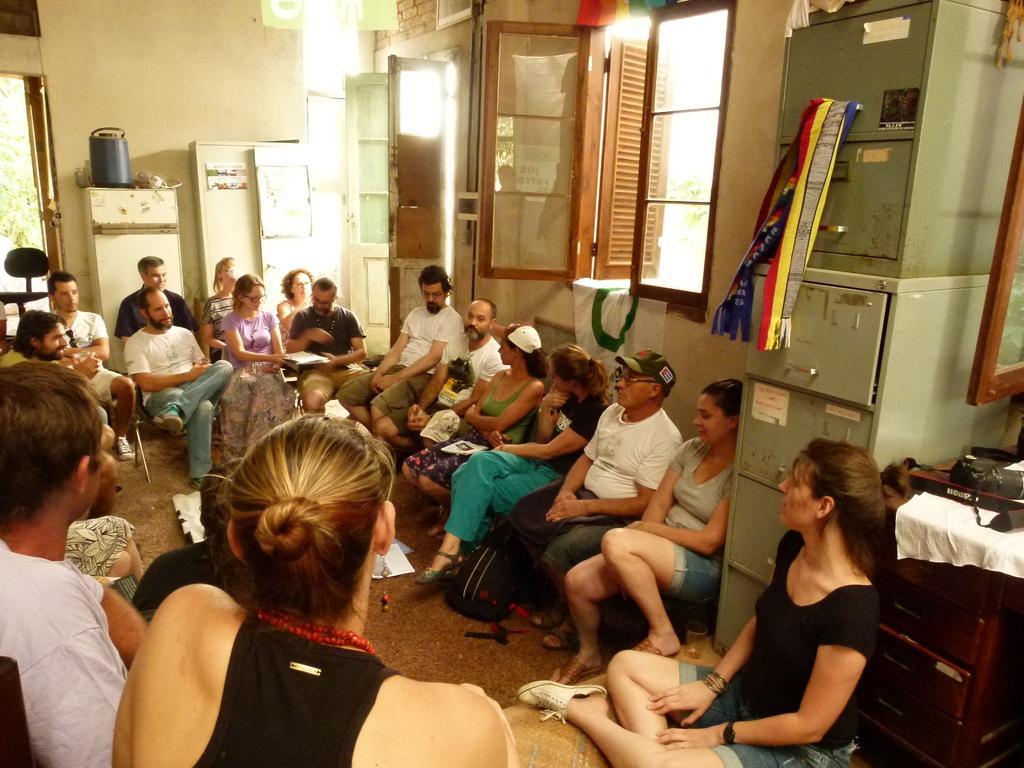Can you describe this image briefly? In this image I can see there is a group of people sitting in a room, there is an iron drawers at right side, there are few doors and windows. 